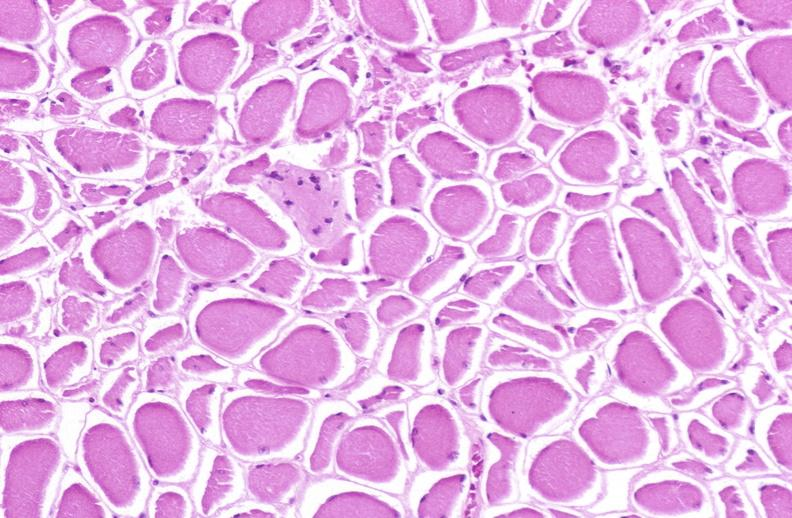what does this image show?
Answer the question using a single word or phrase. Skeletal muscle atrophy 